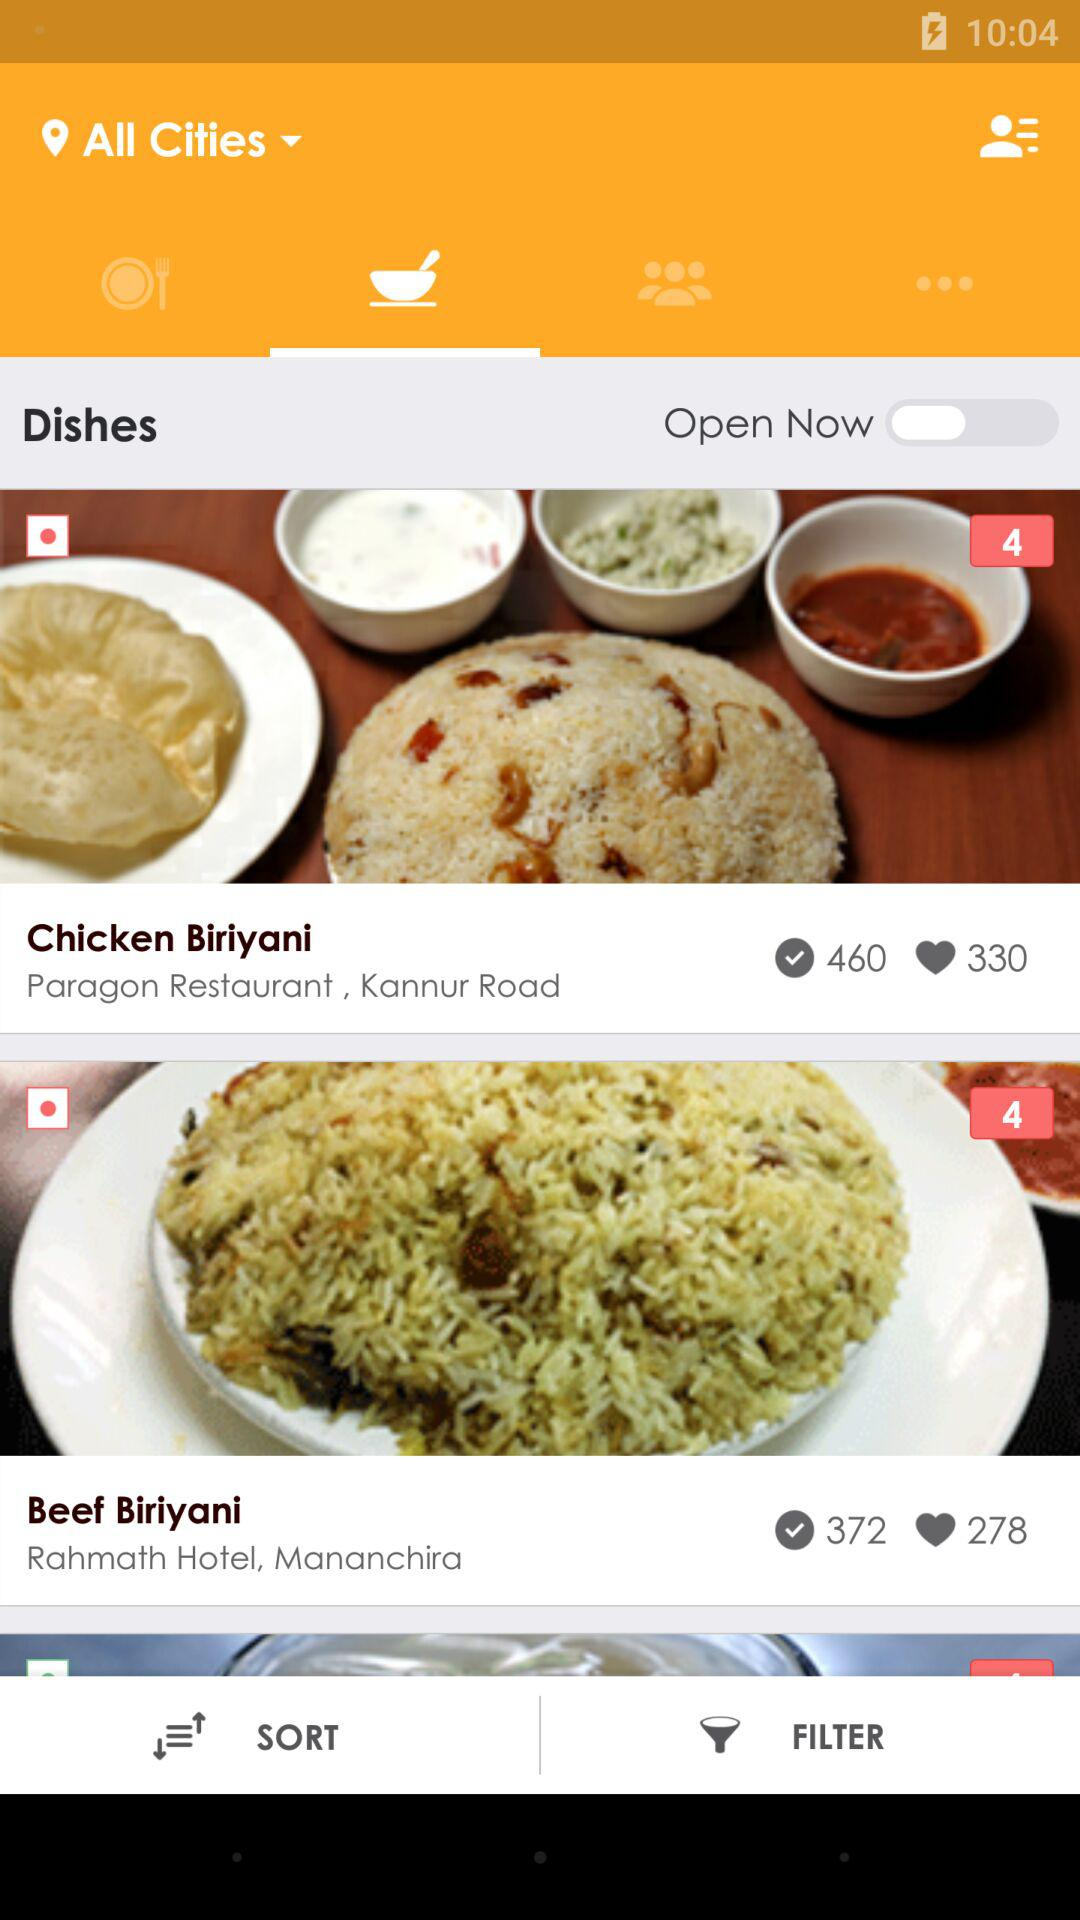How many items have a rating of 4 out of 5?
Answer the question using a single word or phrase. 2 